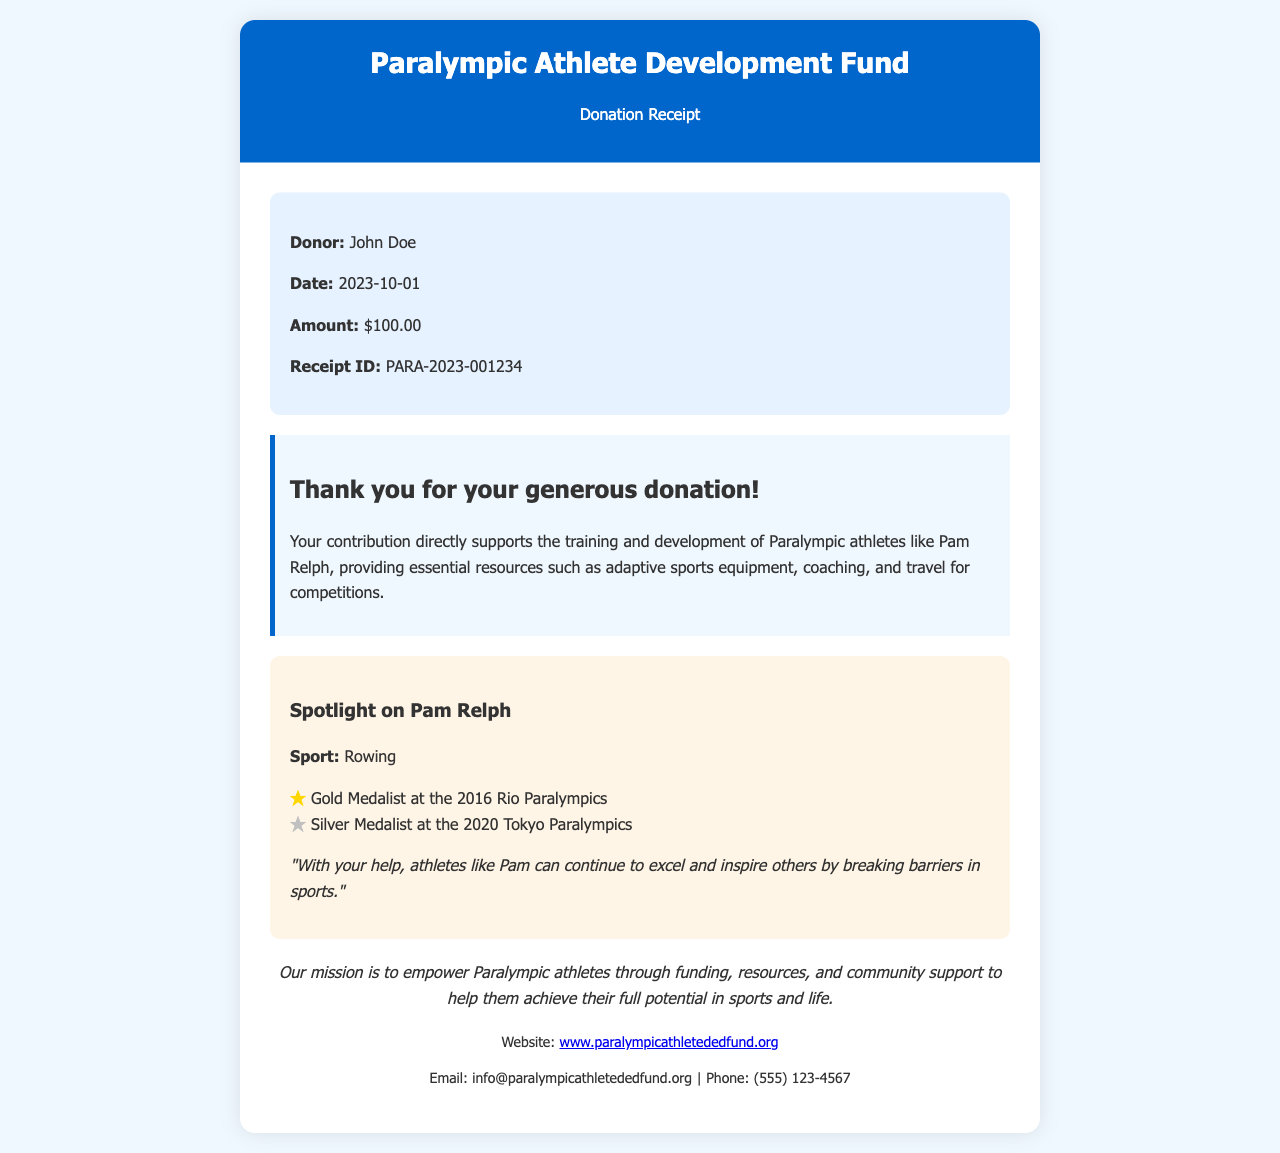What is the name of the donor? The donor's name is mentioned in the receipt details section.
Answer: John Doe What date was the donation made? The date is specified in the receipt details section.
Answer: 2023-10-01 How much was the donation? The amount donated is stated clearly in the receipt details.
Answer: $100.00 What is the receipt ID? The receipt ID can be found in the receipt details section.
Answer: PARA-2023-001234 What is the mission of the organization? The mission is provided in the mission section of the document.
Answer: Empower Paralympic athletes through funding, resources, and community support Which athlete is highlighted in the receipt? The highlighted athlete is mentioned in the athlete story section.
Answer: Pam Relph What medal did Pam Relph win at the 2016 Rio Paralympics? Information about Pam Relph's achievements is detailed in the athlete story section.
Answer: Gold Medalist What resources do donations provide for Paralympic athletes? The impact of the contributions lists essential resources in the impact statement.
Answer: Adaptive sports equipment, coaching, and travel for competitions How can one contact the organization? Contact information is provided in the contact section of the receipt.
Answer: info@paralympicathletededfund.org 